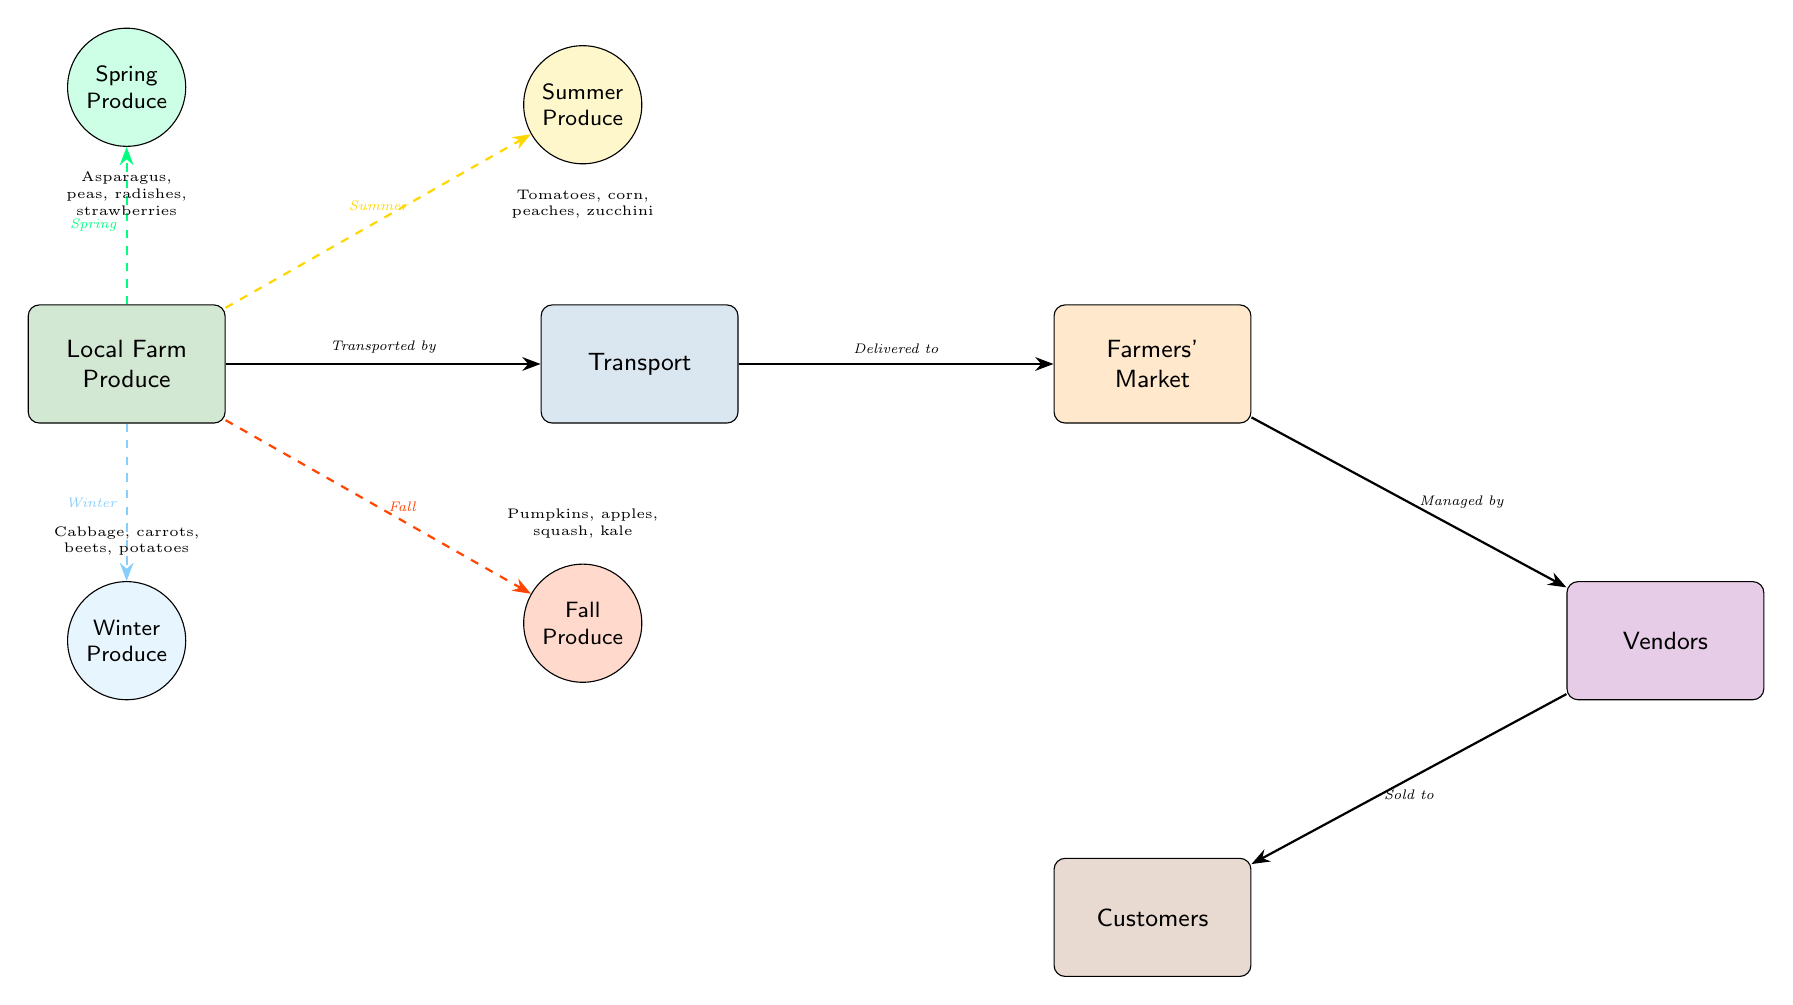What is the first step in the food chain? The food chain begins with the "Local Farm Produce" node, as it represents the initial source of food that progresses through the subsequent stages.
Answer: Local Farm Produce How many seasons are represented in the diagram? The diagram features four distinct seasons: Spring, Summer, Fall, and Winter, indicating a complete yearly cycle of produce.
Answer: 4 What type of produce is harvested in spring? The spring produce includes items such as asparagus, peas, radishes, and strawberries, as noted at the dashed arrow pointing to the Spring node.
Answer: Asparagus, peas, radishes, strawberries What is the relationship between farmers' market and vendors? The relationship is defined as "Managed by," indicating that vendors operate and manage the products sold at the farmers' market.
Answer: Managed by Which produce is associated with the fall season? Fall produce includes pumpkins, apples, squash, and kale, which is specified below the Fall node in the diagram.
Answer: Pumpkins, apples, squash, kale How do local farms affect customer interactions throughout the seasons? Local farms provide seasonal produce that is transported to the market and sold by vendors to customers, indicating that the supply directly influences the availability of products that customers can desire, thereby impacting interactions based on what is in season.
Answer: Seasonal supply influences interactions What happens to the produce after it is transported to the farmers' market? After the produce is transported, it is delivered to the farmers' market, where vendors take charge of selling the items to customers. This flow denotes a critical transition in the food supply chain.
Answer: Delivered to farmers' market During which season are tomatoes typically available? Tomatoes are available in the summer, as indicated by the dashed line connecting the Local Farm Produce to the Summer node.
Answer: Summer Who are the final recipients of the food chain in this diagram? The final recipients of the food chain are customers, who purchase the produce from vendors at the farmers' market.
Answer: Customers What is the color representing winter produce? The winter produce is represented by a node colored in winter blue, visually denoting the seasonal produce associated with winter.
Answer: Winter blue 